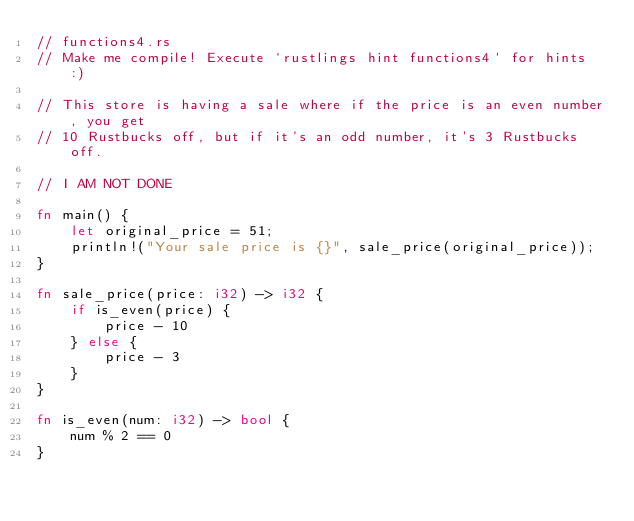Convert code to text. <code><loc_0><loc_0><loc_500><loc_500><_Rust_>// functions4.rs
// Make me compile! Execute `rustlings hint functions4` for hints :)

// This store is having a sale where if the price is an even number, you get
// 10 Rustbucks off, but if it's an odd number, it's 3 Rustbucks off.

// I AM NOT DONE

fn main() {
    let original_price = 51;
    println!("Your sale price is {}", sale_price(original_price));
}

fn sale_price(price: i32) -> i32 {
    if is_even(price) {
        price - 10
    } else {
        price - 3
    }
}

fn is_even(num: i32) -> bool {
    num % 2 == 0
}
</code> 